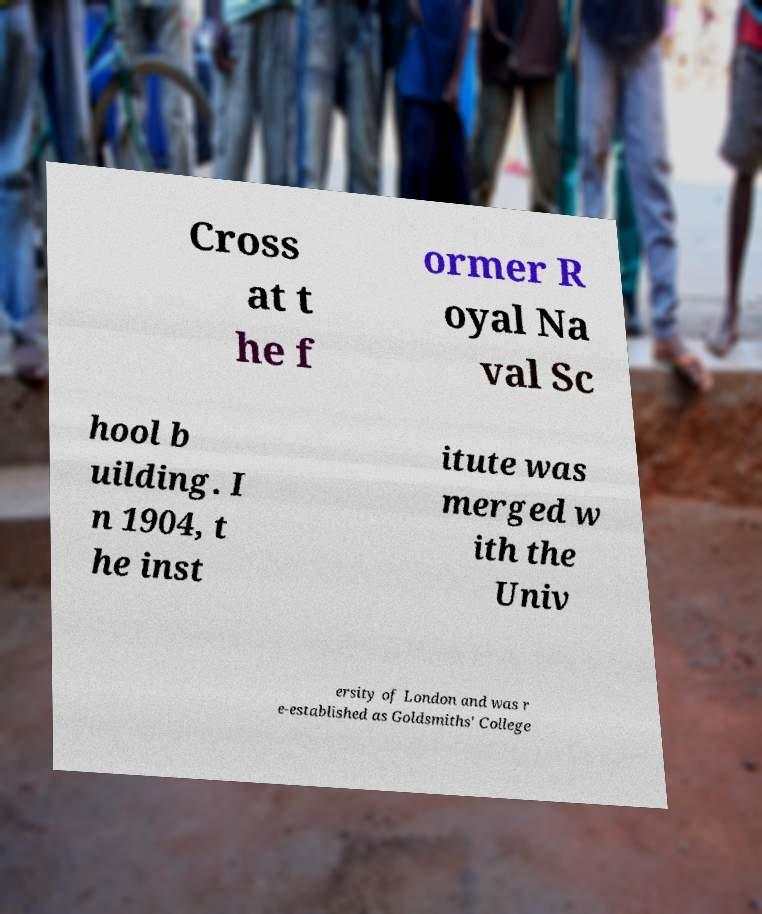For documentation purposes, I need the text within this image transcribed. Could you provide that? Cross at t he f ormer R oyal Na val Sc hool b uilding. I n 1904, t he inst itute was merged w ith the Univ ersity of London and was r e-established as Goldsmiths' College 